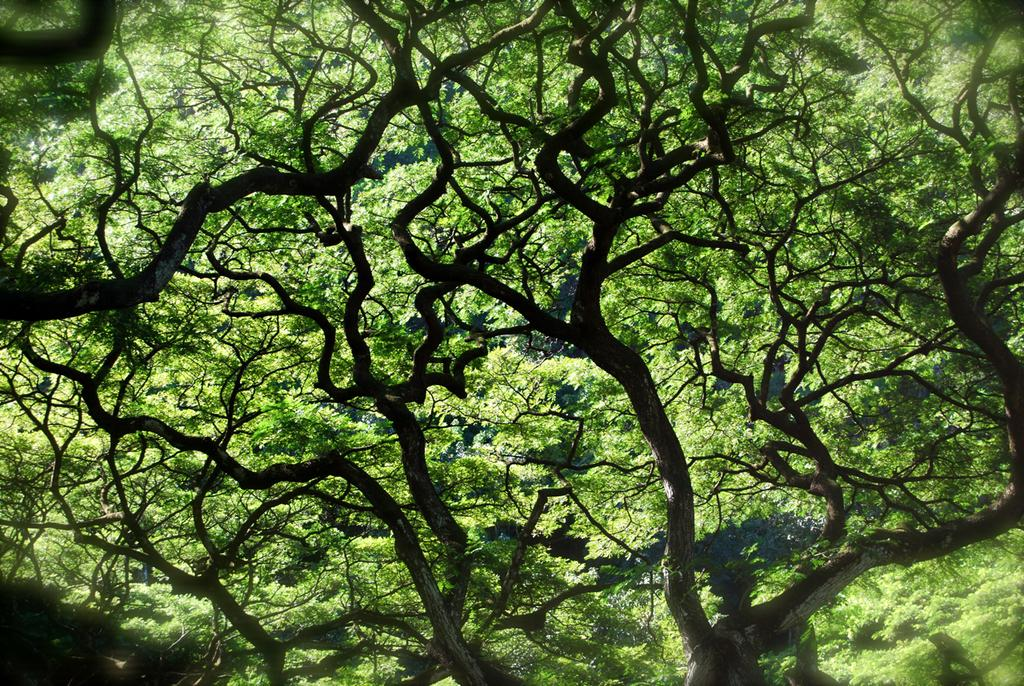What type of vegetation is visible in the image? There are trees in the image. What is the color of the trees in the image? The trees are in green color. What is visible in the sky in the image? The sky is in blue color. What type of behavior can be observed in the trees in the image? The trees in the image are not exhibiting any behavior, as they are inanimate objects. Are the trees in the image sleeping? Trees are not capable of sleeping, as they are inanimate objects. 